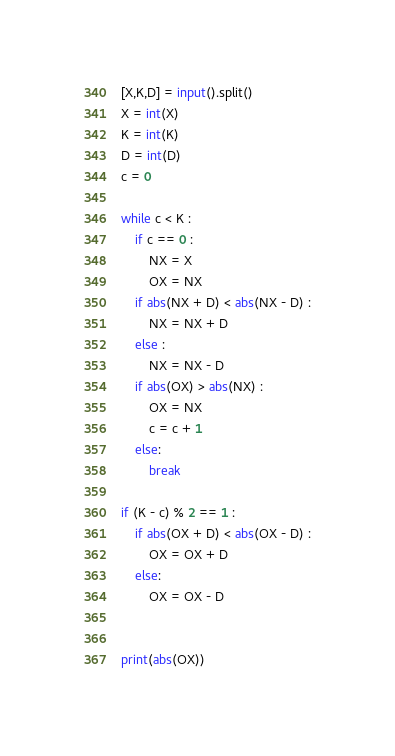<code> <loc_0><loc_0><loc_500><loc_500><_Python_>[X,K,D] = input().split()
X = int(X)
K = int(K)
D = int(D)
c = 0

while c < K :
    if c == 0 :
        NX = X
        OX = NX
    if abs(NX + D) < abs(NX - D) :
        NX = NX + D
    else :
        NX = NX - D
    if abs(OX) > abs(NX) :
        OX = NX
        c = c + 1
    else:
        break

if (K - c) % 2 == 1 :
    if abs(OX + D) < abs(OX - D) :
        OX = OX + D
    else:
        OX = OX - D


print(abs(OX))</code> 